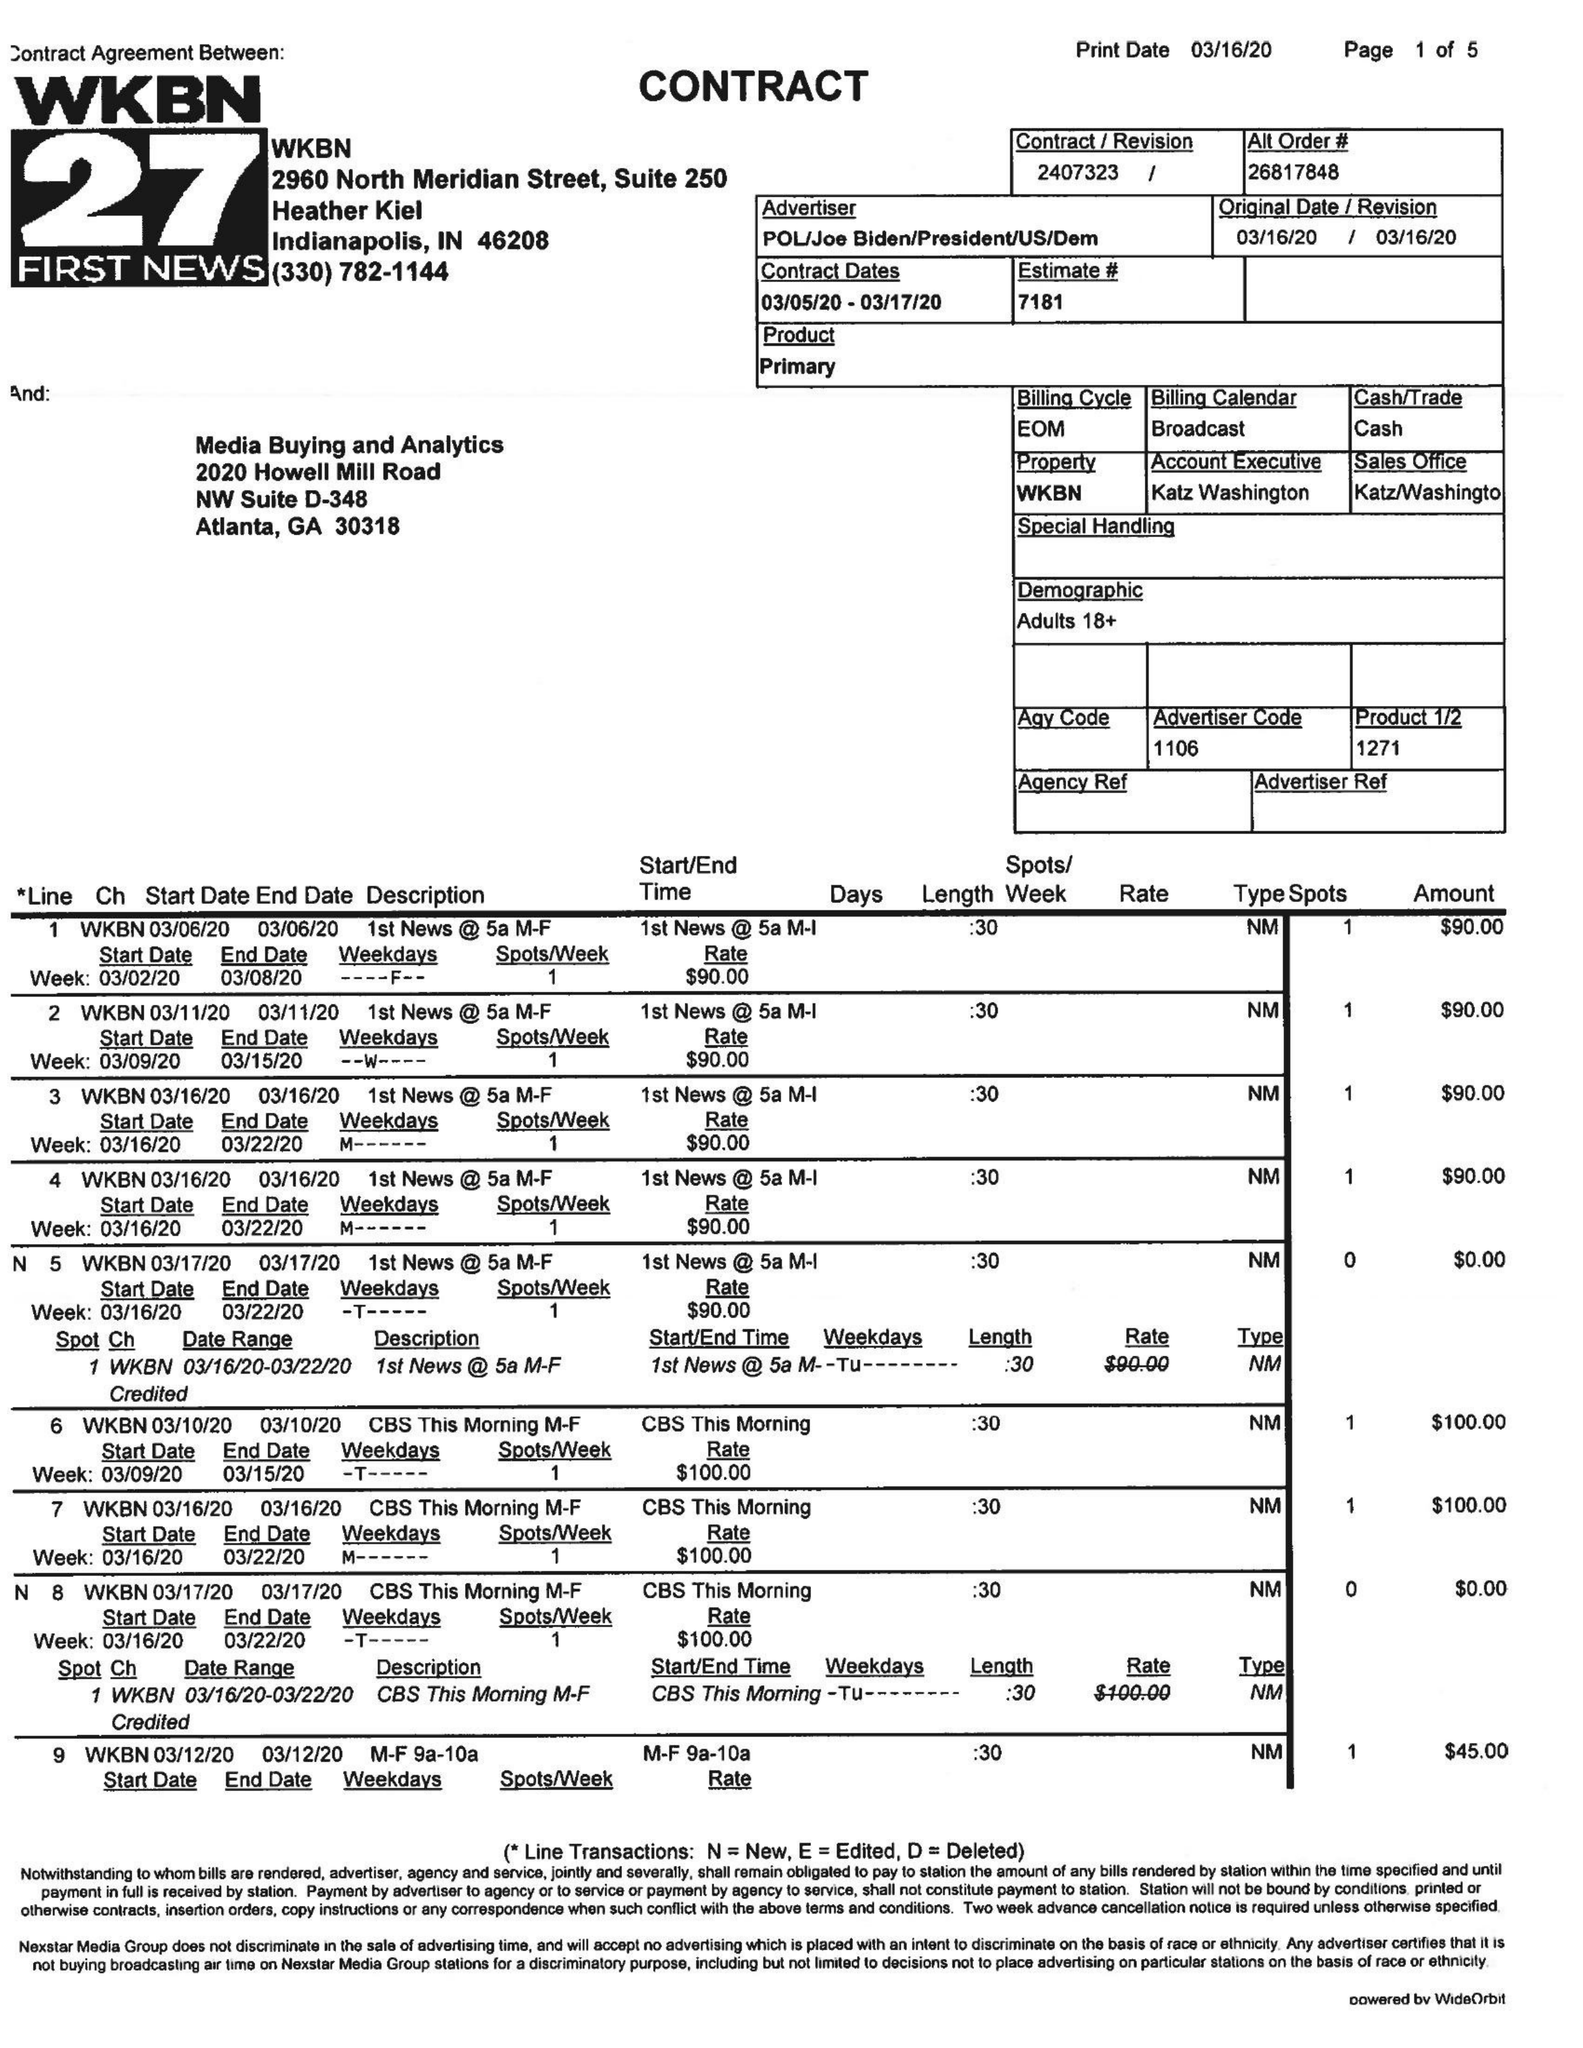What is the value for the flight_from?
Answer the question using a single word or phrase. 03/05/20 